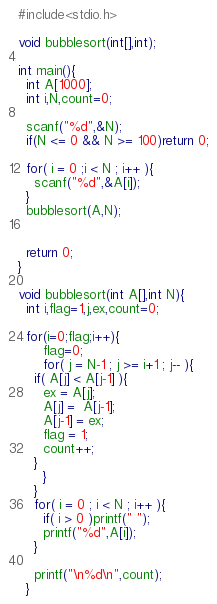<code> <loc_0><loc_0><loc_500><loc_500><_C_>#include<stdio.h>

void bubblesort(int[],int);

int main(){
  int A[1000];
  int i,N,count=0;

  scanf("%d",&N);
  if(N <= 0 && N >= 100)return 0;

  for( i = 0 ;i < N ; i++ ){
    scanf("%d",&A[i]);
  }
  bubblesort(A,N);

  
  return 0;
}

void bubblesort(int A[],int N){
  int i,flag=1,j,ex,count=0;
  
  for(i=0;flag;i++){
      flag=0;
      for( j = N-1 ; j >= i+1 ; j-- ){
	if( A[j] < A[j-1] ){
	  ex = A[j];
	  A[j] =  A[j-1];
	  A[j-1] = ex;
	  flag = 1;
	  count++;
	}
      }
    }
    for( i = 0 ; i < N ; i++ ){
      if( i > 0 )printf(" ");
      printf("%d",A[i]);
    }

    printf("\n%d\n",count);
  }

</code> 